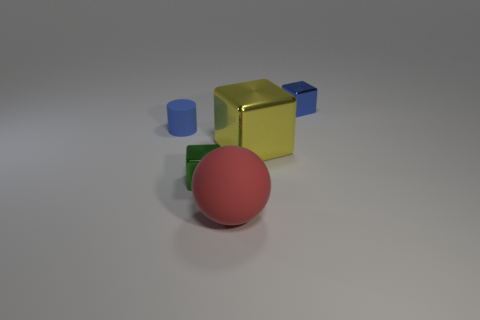What size is the yellow object that is the same shape as the tiny green object?
Your answer should be compact. Large. What number of large green spheres are the same material as the large yellow block?
Ensure brevity in your answer.  0. There is a matte object that is to the right of the small metallic thing that is in front of the blue cube; is there a rubber cylinder that is to the right of it?
Provide a succinct answer. No. What shape is the blue metallic thing?
Offer a very short reply. Cube. Does the blue thing that is in front of the tiny blue block have the same material as the big yellow object that is behind the tiny green shiny object?
Make the answer very short. No. What number of other large objects have the same color as the large rubber object?
Your answer should be very brief. 0. What shape is the metallic thing that is both behind the green thing and in front of the tiny blue matte cylinder?
Make the answer very short. Cube. There is a cube that is in front of the small blue rubber cylinder and to the right of the ball; what is its color?
Ensure brevity in your answer.  Yellow. Are there more tiny blue cubes that are left of the tiny blue metallic cube than big objects to the right of the big metal thing?
Give a very brief answer. No. There is a rubber object on the right side of the green shiny thing; what color is it?
Provide a succinct answer. Red. 